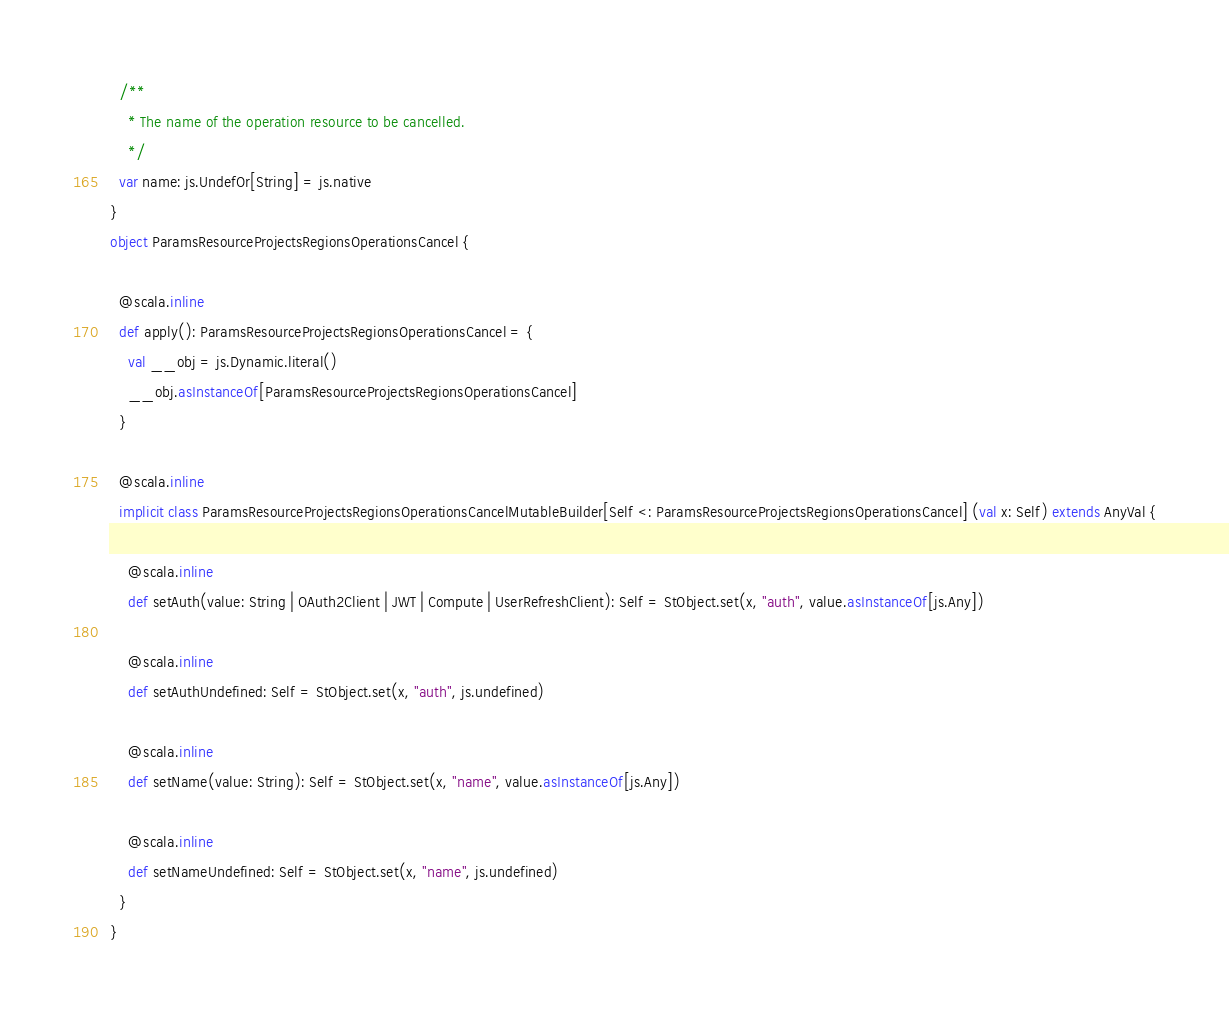<code> <loc_0><loc_0><loc_500><loc_500><_Scala_>  /**
    * The name of the operation resource to be cancelled.
    */
  var name: js.UndefOr[String] = js.native
}
object ParamsResourceProjectsRegionsOperationsCancel {
  
  @scala.inline
  def apply(): ParamsResourceProjectsRegionsOperationsCancel = {
    val __obj = js.Dynamic.literal()
    __obj.asInstanceOf[ParamsResourceProjectsRegionsOperationsCancel]
  }
  
  @scala.inline
  implicit class ParamsResourceProjectsRegionsOperationsCancelMutableBuilder[Self <: ParamsResourceProjectsRegionsOperationsCancel] (val x: Self) extends AnyVal {
    
    @scala.inline
    def setAuth(value: String | OAuth2Client | JWT | Compute | UserRefreshClient): Self = StObject.set(x, "auth", value.asInstanceOf[js.Any])
    
    @scala.inline
    def setAuthUndefined: Self = StObject.set(x, "auth", js.undefined)
    
    @scala.inline
    def setName(value: String): Self = StObject.set(x, "name", value.asInstanceOf[js.Any])
    
    @scala.inline
    def setNameUndefined: Self = StObject.set(x, "name", js.undefined)
  }
}
</code> 